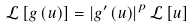Convert formula to latex. <formula><loc_0><loc_0><loc_500><loc_500>\mathcal { L } \left [ g \left ( u \right ) \right ] = \left | g ^ { \prime } \left ( u \right ) \right | ^ { p } \mathcal { L } \left [ u \right ]</formula> 